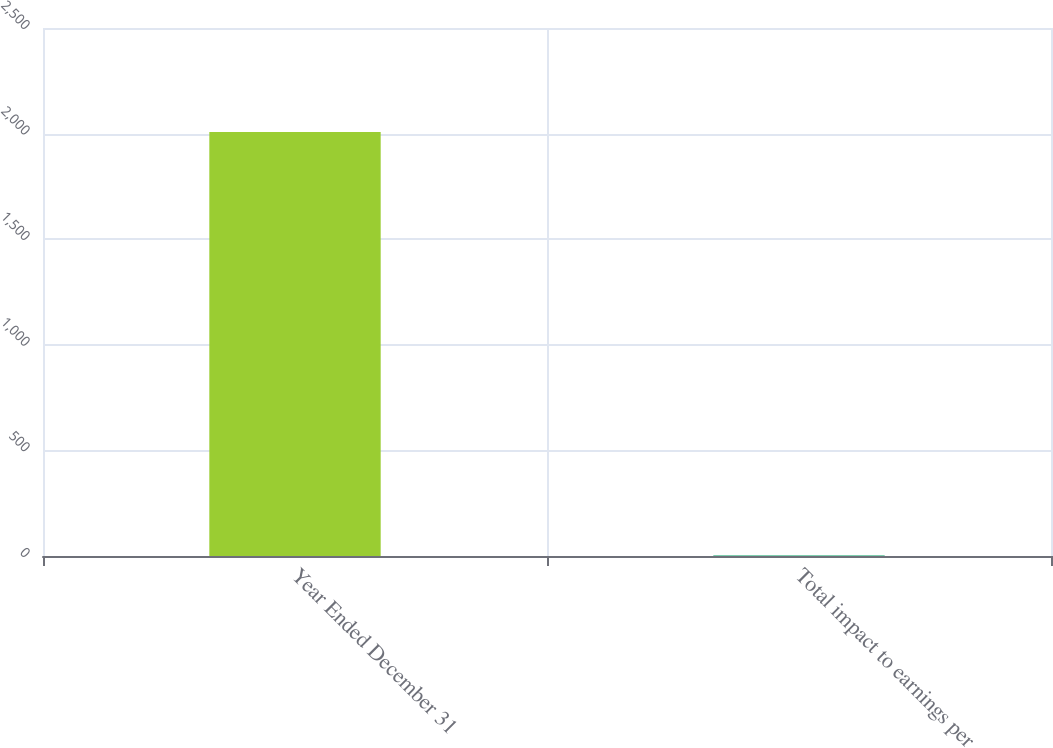Convert chart. <chart><loc_0><loc_0><loc_500><loc_500><bar_chart><fcel>Year Ended December 31<fcel>Total impact to earnings per<nl><fcel>2008<fcel>2.38<nl></chart> 